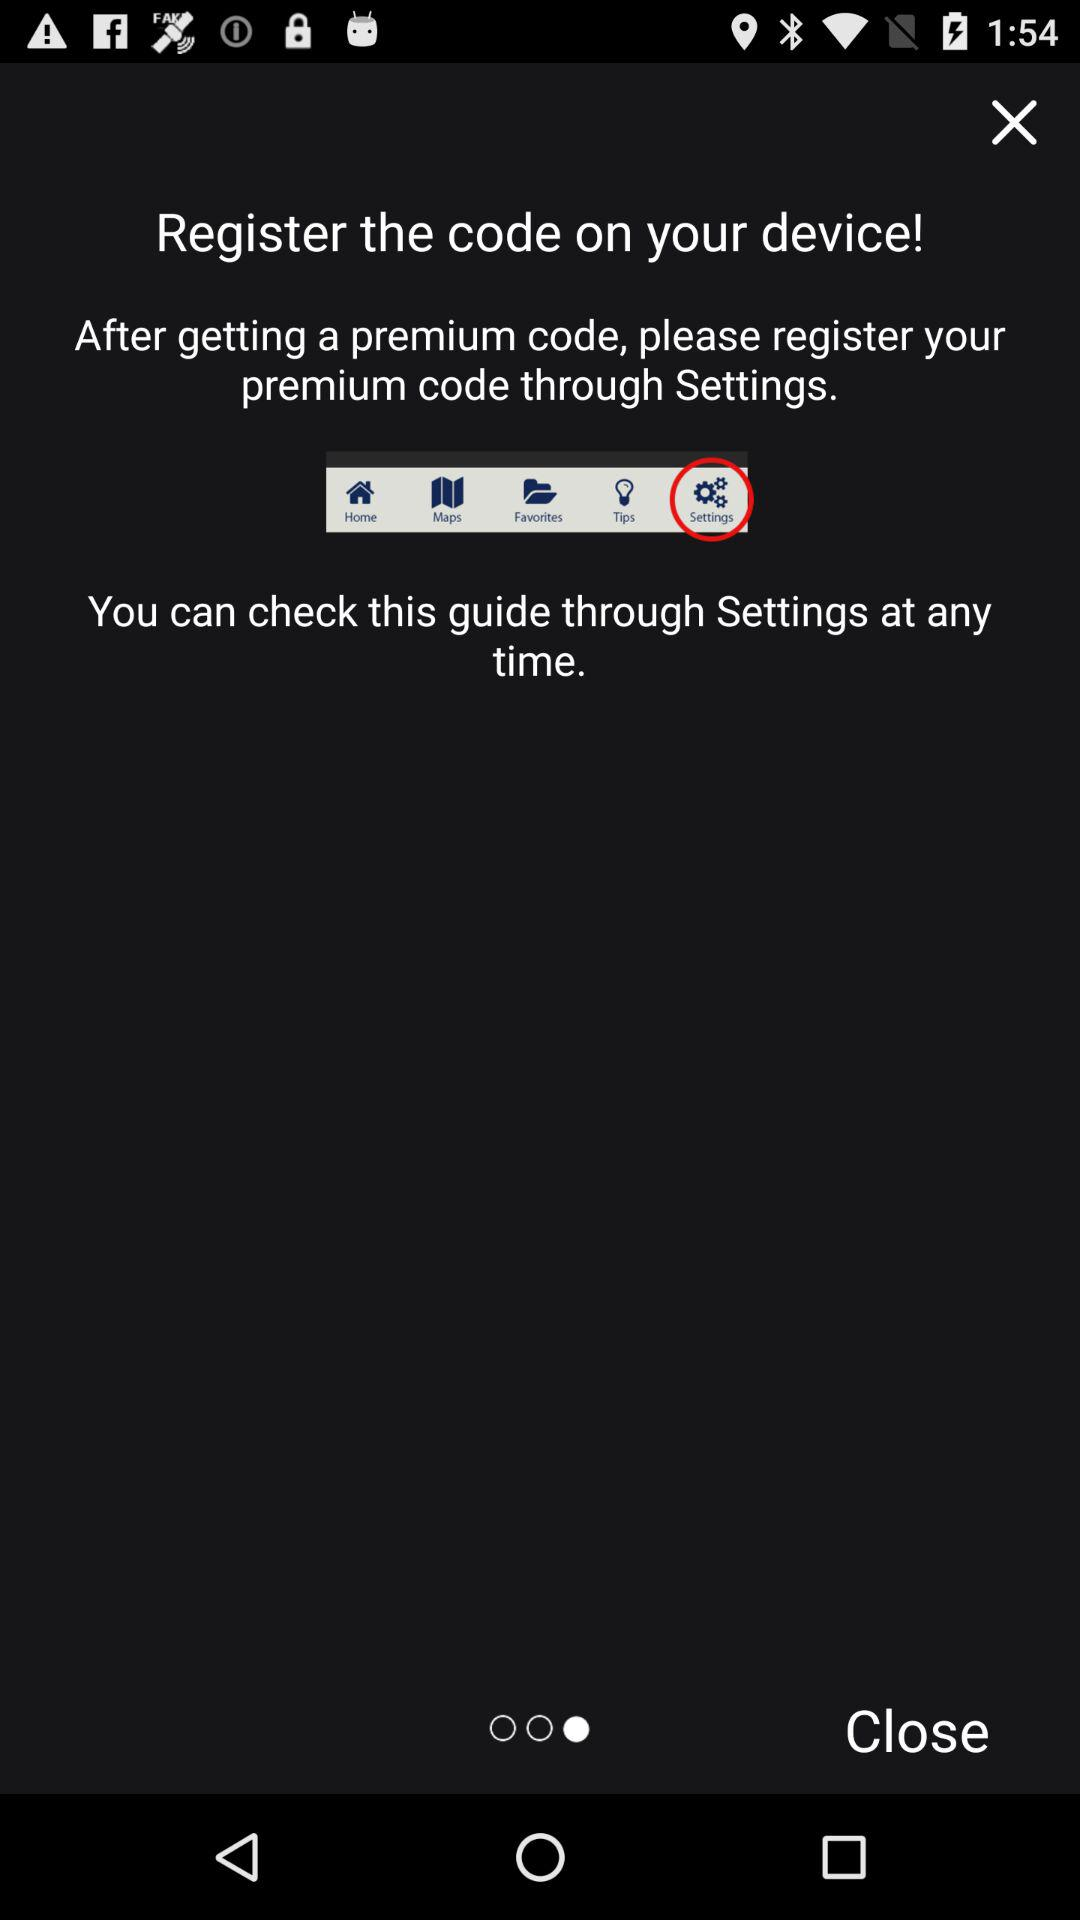Through which code you can register?
When the provided information is insufficient, respond with <no answer>. <no answer> 